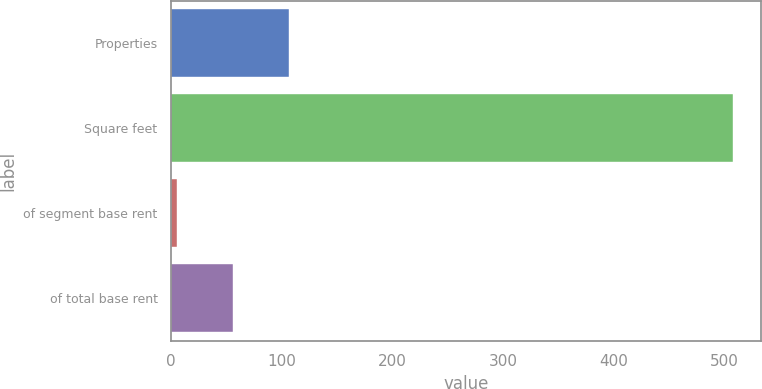Convert chart. <chart><loc_0><loc_0><loc_500><loc_500><bar_chart><fcel>Properties<fcel>Square feet<fcel>of segment base rent<fcel>of total base rent<nl><fcel>106.4<fcel>508<fcel>6<fcel>56.2<nl></chart> 